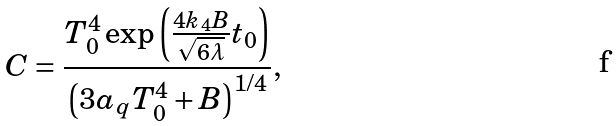<formula> <loc_0><loc_0><loc_500><loc_500>C = \frac { T _ { 0 } ^ { 4 } \exp \left ( \frac { 4 k _ { 4 } B } { \sqrt { 6 \lambda } } t _ { 0 } \right ) } { \left ( 3 a _ { q } T _ { 0 } ^ { 4 } + B \right ) ^ { 1 / 4 } } ,</formula> 